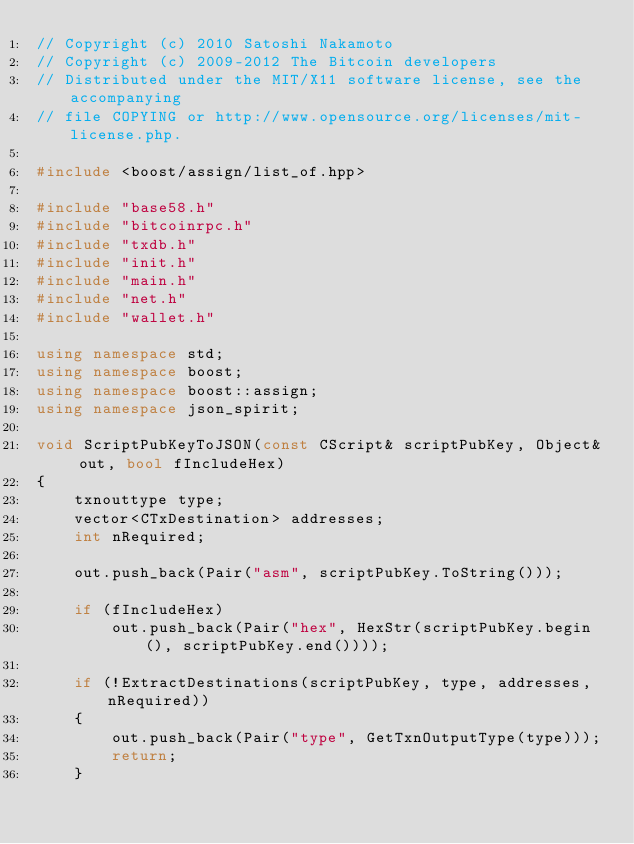Convert code to text. <code><loc_0><loc_0><loc_500><loc_500><_C++_>// Copyright (c) 2010 Satoshi Nakamoto
// Copyright (c) 2009-2012 The Bitcoin developers
// Distributed under the MIT/X11 software license, see the accompanying
// file COPYING or http://www.opensource.org/licenses/mit-license.php.

#include <boost/assign/list_of.hpp>

#include "base58.h"
#include "bitcoinrpc.h"
#include "txdb.h"
#include "init.h"
#include "main.h"
#include "net.h"
#include "wallet.h"

using namespace std;
using namespace boost;
using namespace boost::assign;
using namespace json_spirit;

void ScriptPubKeyToJSON(const CScript& scriptPubKey, Object& out, bool fIncludeHex)
{
    txnouttype type;
    vector<CTxDestination> addresses;
    int nRequired;

    out.push_back(Pair("asm", scriptPubKey.ToString()));

    if (fIncludeHex)
        out.push_back(Pair("hex", HexStr(scriptPubKey.begin(), scriptPubKey.end())));

    if (!ExtractDestinations(scriptPubKey, type, addresses, nRequired))
    {
        out.push_back(Pair("type", GetTxnOutputType(type)));
        return;
    }
</code> 